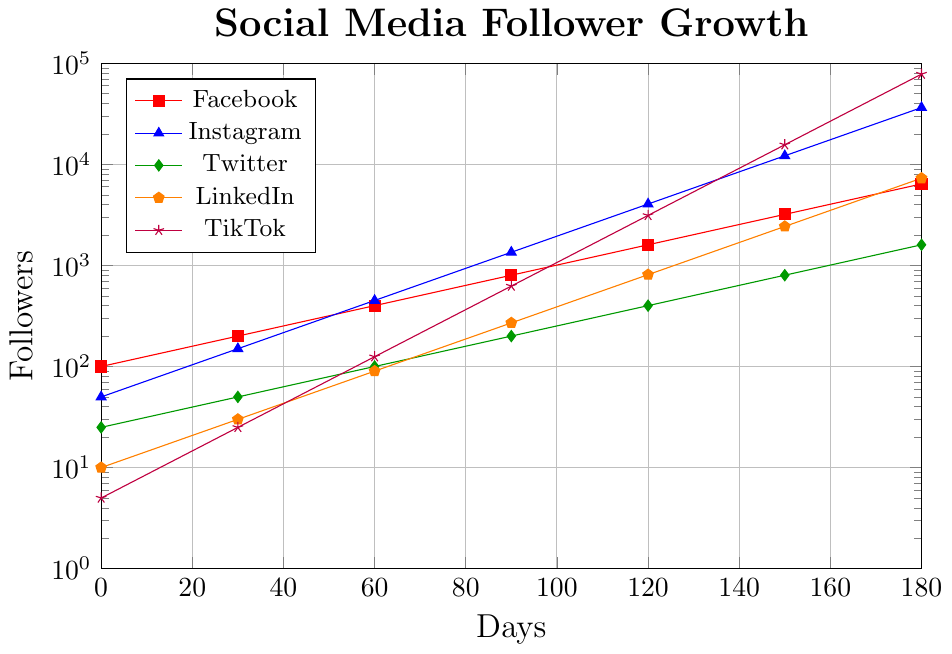Which platform has the highest growth rate in follower count? By visually inspecting the slopes of the lines, TikTok's line has the steepest incline, indicating the highest growth rate.
Answer: TikTok Between Instagram and Facebook, which platform had more followers after 60 days? At 60 days, Instagram had 450 followers, while Facebook had 400 followers.
Answer: Instagram What is the difference in follower count between TikTok and LinkedIn at 180 days? At 180 days, TikTok has 78,125 followers, and LinkedIn has 7,290 followers. The difference is 78,125 - 7,290 = 70,835.
Answer: 70,835 How many platforms have a follower count above 10,000 at 150 days? At 150 days, Instagram and TikTok have follower counts exceeding 10,000 (12,150 and 15,625 respectively).
Answer: 2 Which platform had the slowest initial growth in the first 30 days? Between 0 and 30 days, TikTok started with 5 followers and reached 25, exhibiting the slowest initial growth.
Answer: TikTok What is the average follower count for Facebook at 0, 60, and 120 days? The follower counts for Facebook at 0, 60, and 120 days are 100, 400, and 1600 respectively. The average is (100 + 400 + 1600) / 3 = 700.
Answer: 700 Compare the follower count of Twitter and LinkedIn at 120 days. Which has more, and by how much? At 120 days, Twitter has 400 followers, and LinkedIn has 810 followers. LinkedIn has more followers by 810 - 400 = 410.
Answer: LinkedIn, 410 What is the combined follower count for all platforms at 90 days? At 90 days, the follower counts are: Facebook (800), Instagram (1350), Twitter (200), LinkedIn (270), TikTok (625). Combined, this gives 800 + 1350 + 200 + 270 + 625 = 3245.
Answer: 3245 